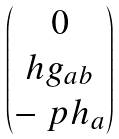<formula> <loc_0><loc_0><loc_500><loc_500>\begin{pmatrix} 0 \\ h g _ { a b } \\ - \ p h _ { a } \end{pmatrix}</formula> 